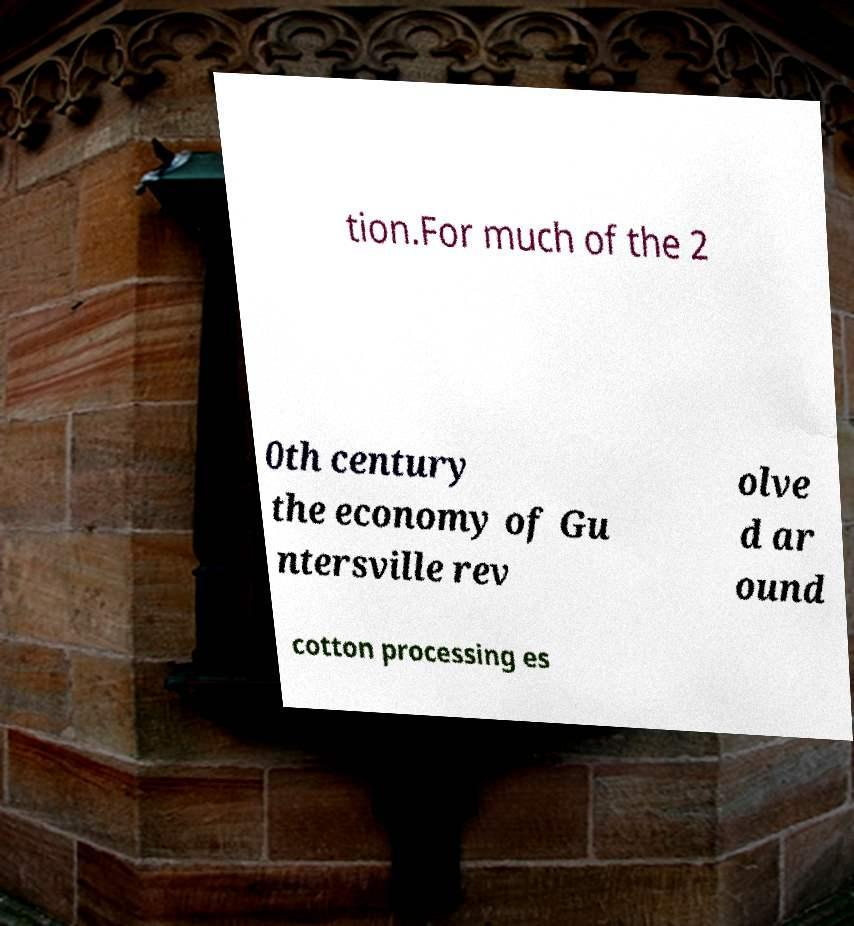There's text embedded in this image that I need extracted. Can you transcribe it verbatim? tion.For much of the 2 0th century the economy of Gu ntersville rev olve d ar ound cotton processing es 